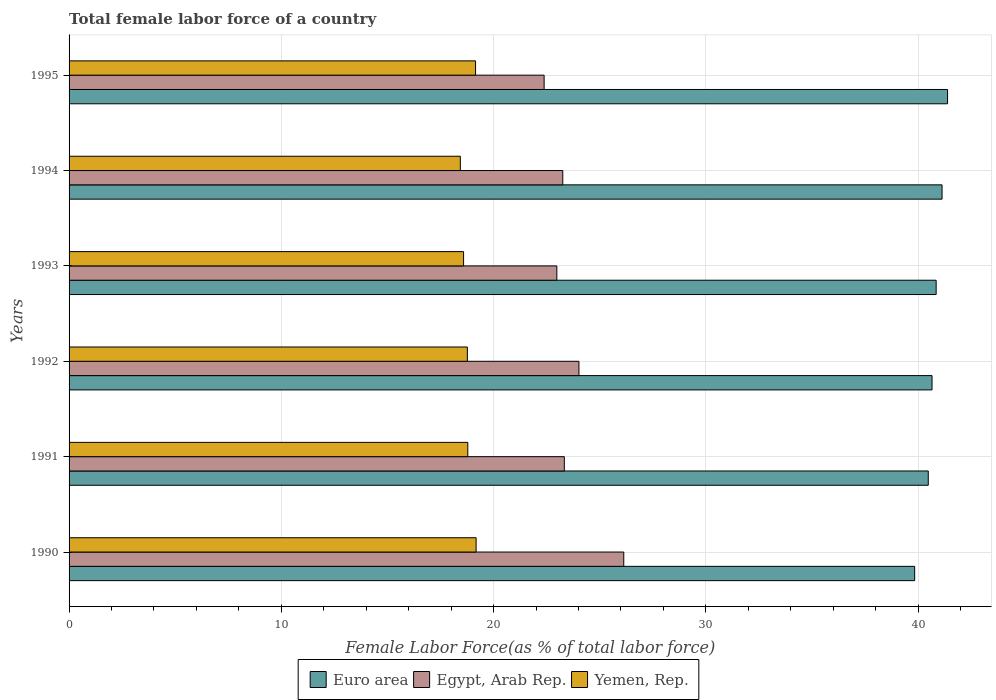How many different coloured bars are there?
Provide a short and direct response. 3. How many groups of bars are there?
Offer a terse response. 6. Are the number of bars per tick equal to the number of legend labels?
Your answer should be compact. Yes. Are the number of bars on each tick of the Y-axis equal?
Give a very brief answer. Yes. How many bars are there on the 5th tick from the top?
Offer a very short reply. 3. What is the label of the 2nd group of bars from the top?
Provide a succinct answer. 1994. In how many cases, is the number of bars for a given year not equal to the number of legend labels?
Make the answer very short. 0. What is the percentage of female labor force in Euro area in 1993?
Provide a succinct answer. 40.85. Across all years, what is the maximum percentage of female labor force in Egypt, Arab Rep.?
Provide a short and direct response. 26.14. Across all years, what is the minimum percentage of female labor force in Egypt, Arab Rep.?
Your answer should be compact. 22.38. In which year was the percentage of female labor force in Egypt, Arab Rep. maximum?
Make the answer very short. 1990. In which year was the percentage of female labor force in Egypt, Arab Rep. minimum?
Ensure brevity in your answer.  1995. What is the total percentage of female labor force in Egypt, Arab Rep. in the graph?
Provide a succinct answer. 142.12. What is the difference between the percentage of female labor force in Egypt, Arab Rep. in 1990 and that in 1991?
Provide a short and direct response. 2.8. What is the difference between the percentage of female labor force in Yemen, Rep. in 1990 and the percentage of female labor force in Euro area in 1994?
Ensure brevity in your answer.  -21.95. What is the average percentage of female labor force in Egypt, Arab Rep. per year?
Make the answer very short. 23.69. In the year 1991, what is the difference between the percentage of female labor force in Yemen, Rep. and percentage of female labor force in Euro area?
Give a very brief answer. -21.7. What is the ratio of the percentage of female labor force in Euro area in 1990 to that in 1992?
Your response must be concise. 0.98. Is the percentage of female labor force in Egypt, Arab Rep. in 1991 less than that in 1993?
Keep it short and to the point. No. What is the difference between the highest and the second highest percentage of female labor force in Yemen, Rep.?
Provide a short and direct response. 0.03. What is the difference between the highest and the lowest percentage of female labor force in Egypt, Arab Rep.?
Give a very brief answer. 3.75. What does the 3rd bar from the bottom in 1995 represents?
Your answer should be compact. Yemen, Rep. Is it the case that in every year, the sum of the percentage of female labor force in Egypt, Arab Rep. and percentage of female labor force in Euro area is greater than the percentage of female labor force in Yemen, Rep.?
Make the answer very short. Yes. Are all the bars in the graph horizontal?
Offer a terse response. Yes. What is the difference between two consecutive major ticks on the X-axis?
Offer a very short reply. 10. Does the graph contain grids?
Provide a succinct answer. Yes. Where does the legend appear in the graph?
Your answer should be very brief. Bottom center. How many legend labels are there?
Give a very brief answer. 3. What is the title of the graph?
Make the answer very short. Total female labor force of a country. What is the label or title of the X-axis?
Keep it short and to the point. Female Labor Force(as % of total labor force). What is the Female Labor Force(as % of total labor force) in Euro area in 1990?
Offer a very short reply. 39.84. What is the Female Labor Force(as % of total labor force) in Egypt, Arab Rep. in 1990?
Your response must be concise. 26.14. What is the Female Labor Force(as % of total labor force) of Yemen, Rep. in 1990?
Provide a succinct answer. 19.18. What is the Female Labor Force(as % of total labor force) of Euro area in 1991?
Your answer should be very brief. 40.48. What is the Female Labor Force(as % of total labor force) in Egypt, Arab Rep. in 1991?
Your answer should be compact. 23.34. What is the Female Labor Force(as % of total labor force) in Yemen, Rep. in 1991?
Make the answer very short. 18.79. What is the Female Labor Force(as % of total labor force) in Euro area in 1992?
Your answer should be very brief. 40.66. What is the Female Labor Force(as % of total labor force) in Egypt, Arab Rep. in 1992?
Provide a succinct answer. 24.02. What is the Female Labor Force(as % of total labor force) of Yemen, Rep. in 1992?
Offer a terse response. 18.77. What is the Female Labor Force(as % of total labor force) of Euro area in 1993?
Your answer should be compact. 40.85. What is the Female Labor Force(as % of total labor force) of Egypt, Arab Rep. in 1993?
Ensure brevity in your answer.  22.98. What is the Female Labor Force(as % of total labor force) of Yemen, Rep. in 1993?
Your response must be concise. 18.59. What is the Female Labor Force(as % of total labor force) in Euro area in 1994?
Give a very brief answer. 41.13. What is the Female Labor Force(as % of total labor force) in Egypt, Arab Rep. in 1994?
Ensure brevity in your answer.  23.26. What is the Female Labor Force(as % of total labor force) of Yemen, Rep. in 1994?
Your answer should be compact. 18.44. What is the Female Labor Force(as % of total labor force) in Euro area in 1995?
Give a very brief answer. 41.39. What is the Female Labor Force(as % of total labor force) of Egypt, Arab Rep. in 1995?
Ensure brevity in your answer.  22.38. What is the Female Labor Force(as % of total labor force) of Yemen, Rep. in 1995?
Your answer should be very brief. 19.15. Across all years, what is the maximum Female Labor Force(as % of total labor force) of Euro area?
Ensure brevity in your answer.  41.39. Across all years, what is the maximum Female Labor Force(as % of total labor force) of Egypt, Arab Rep.?
Your response must be concise. 26.14. Across all years, what is the maximum Female Labor Force(as % of total labor force) in Yemen, Rep.?
Provide a short and direct response. 19.18. Across all years, what is the minimum Female Labor Force(as % of total labor force) in Euro area?
Offer a very short reply. 39.84. Across all years, what is the minimum Female Labor Force(as % of total labor force) of Egypt, Arab Rep.?
Your answer should be very brief. 22.38. Across all years, what is the minimum Female Labor Force(as % of total labor force) in Yemen, Rep.?
Keep it short and to the point. 18.44. What is the total Female Labor Force(as % of total labor force) of Euro area in the graph?
Offer a very short reply. 244.36. What is the total Female Labor Force(as % of total labor force) of Egypt, Arab Rep. in the graph?
Provide a succinct answer. 142.12. What is the total Female Labor Force(as % of total labor force) of Yemen, Rep. in the graph?
Ensure brevity in your answer.  112.91. What is the difference between the Female Labor Force(as % of total labor force) in Euro area in 1990 and that in 1991?
Give a very brief answer. -0.64. What is the difference between the Female Labor Force(as % of total labor force) in Yemen, Rep. in 1990 and that in 1991?
Ensure brevity in your answer.  0.39. What is the difference between the Female Labor Force(as % of total labor force) in Euro area in 1990 and that in 1992?
Your answer should be very brief. -0.82. What is the difference between the Female Labor Force(as % of total labor force) of Egypt, Arab Rep. in 1990 and that in 1992?
Offer a terse response. 2.11. What is the difference between the Female Labor Force(as % of total labor force) of Yemen, Rep. in 1990 and that in 1992?
Your response must be concise. 0.41. What is the difference between the Female Labor Force(as % of total labor force) in Euro area in 1990 and that in 1993?
Keep it short and to the point. -1.01. What is the difference between the Female Labor Force(as % of total labor force) in Egypt, Arab Rep. in 1990 and that in 1993?
Offer a very short reply. 3.15. What is the difference between the Female Labor Force(as % of total labor force) of Yemen, Rep. in 1990 and that in 1993?
Ensure brevity in your answer.  0.59. What is the difference between the Female Labor Force(as % of total labor force) of Euro area in 1990 and that in 1994?
Give a very brief answer. -1.29. What is the difference between the Female Labor Force(as % of total labor force) in Egypt, Arab Rep. in 1990 and that in 1994?
Provide a short and direct response. 2.87. What is the difference between the Female Labor Force(as % of total labor force) in Yemen, Rep. in 1990 and that in 1994?
Offer a very short reply. 0.74. What is the difference between the Female Labor Force(as % of total labor force) in Euro area in 1990 and that in 1995?
Your response must be concise. -1.55. What is the difference between the Female Labor Force(as % of total labor force) in Egypt, Arab Rep. in 1990 and that in 1995?
Offer a terse response. 3.75. What is the difference between the Female Labor Force(as % of total labor force) of Yemen, Rep. in 1990 and that in 1995?
Give a very brief answer. 0.03. What is the difference between the Female Labor Force(as % of total labor force) of Euro area in 1991 and that in 1992?
Provide a short and direct response. -0.18. What is the difference between the Female Labor Force(as % of total labor force) in Egypt, Arab Rep. in 1991 and that in 1992?
Your answer should be very brief. -0.69. What is the difference between the Female Labor Force(as % of total labor force) in Yemen, Rep. in 1991 and that in 1992?
Provide a succinct answer. 0.02. What is the difference between the Female Labor Force(as % of total labor force) in Euro area in 1991 and that in 1993?
Provide a succinct answer. -0.37. What is the difference between the Female Labor Force(as % of total labor force) of Egypt, Arab Rep. in 1991 and that in 1993?
Provide a short and direct response. 0.35. What is the difference between the Female Labor Force(as % of total labor force) in Yemen, Rep. in 1991 and that in 1993?
Your answer should be compact. 0.2. What is the difference between the Female Labor Force(as % of total labor force) of Euro area in 1991 and that in 1994?
Offer a terse response. -0.65. What is the difference between the Female Labor Force(as % of total labor force) of Egypt, Arab Rep. in 1991 and that in 1994?
Your answer should be very brief. 0.07. What is the difference between the Female Labor Force(as % of total labor force) in Yemen, Rep. in 1991 and that in 1994?
Make the answer very short. 0.35. What is the difference between the Female Labor Force(as % of total labor force) in Euro area in 1991 and that in 1995?
Provide a succinct answer. -0.91. What is the difference between the Female Labor Force(as % of total labor force) of Egypt, Arab Rep. in 1991 and that in 1995?
Your response must be concise. 0.95. What is the difference between the Female Labor Force(as % of total labor force) in Yemen, Rep. in 1991 and that in 1995?
Offer a terse response. -0.37. What is the difference between the Female Labor Force(as % of total labor force) in Euro area in 1992 and that in 1993?
Keep it short and to the point. -0.19. What is the difference between the Female Labor Force(as % of total labor force) of Egypt, Arab Rep. in 1992 and that in 1993?
Your response must be concise. 1.04. What is the difference between the Female Labor Force(as % of total labor force) of Yemen, Rep. in 1992 and that in 1993?
Offer a terse response. 0.18. What is the difference between the Female Labor Force(as % of total labor force) of Euro area in 1992 and that in 1994?
Your response must be concise. -0.47. What is the difference between the Female Labor Force(as % of total labor force) in Egypt, Arab Rep. in 1992 and that in 1994?
Your response must be concise. 0.76. What is the difference between the Female Labor Force(as % of total labor force) of Yemen, Rep. in 1992 and that in 1994?
Ensure brevity in your answer.  0.33. What is the difference between the Female Labor Force(as % of total labor force) of Euro area in 1992 and that in 1995?
Your response must be concise. -0.73. What is the difference between the Female Labor Force(as % of total labor force) of Egypt, Arab Rep. in 1992 and that in 1995?
Your response must be concise. 1.64. What is the difference between the Female Labor Force(as % of total labor force) of Yemen, Rep. in 1992 and that in 1995?
Ensure brevity in your answer.  -0.39. What is the difference between the Female Labor Force(as % of total labor force) in Euro area in 1993 and that in 1994?
Give a very brief answer. -0.28. What is the difference between the Female Labor Force(as % of total labor force) in Egypt, Arab Rep. in 1993 and that in 1994?
Provide a succinct answer. -0.28. What is the difference between the Female Labor Force(as % of total labor force) in Yemen, Rep. in 1993 and that in 1994?
Offer a terse response. 0.15. What is the difference between the Female Labor Force(as % of total labor force) in Euro area in 1993 and that in 1995?
Make the answer very short. -0.54. What is the difference between the Female Labor Force(as % of total labor force) of Egypt, Arab Rep. in 1993 and that in 1995?
Keep it short and to the point. 0.6. What is the difference between the Female Labor Force(as % of total labor force) of Yemen, Rep. in 1993 and that in 1995?
Keep it short and to the point. -0.56. What is the difference between the Female Labor Force(as % of total labor force) in Euro area in 1994 and that in 1995?
Your response must be concise. -0.26. What is the difference between the Female Labor Force(as % of total labor force) of Egypt, Arab Rep. in 1994 and that in 1995?
Offer a terse response. 0.88. What is the difference between the Female Labor Force(as % of total labor force) in Yemen, Rep. in 1994 and that in 1995?
Your answer should be very brief. -0.72. What is the difference between the Female Labor Force(as % of total labor force) in Euro area in 1990 and the Female Labor Force(as % of total labor force) in Egypt, Arab Rep. in 1991?
Make the answer very short. 16.51. What is the difference between the Female Labor Force(as % of total labor force) in Euro area in 1990 and the Female Labor Force(as % of total labor force) in Yemen, Rep. in 1991?
Make the answer very short. 21.06. What is the difference between the Female Labor Force(as % of total labor force) of Egypt, Arab Rep. in 1990 and the Female Labor Force(as % of total labor force) of Yemen, Rep. in 1991?
Your answer should be compact. 7.35. What is the difference between the Female Labor Force(as % of total labor force) of Euro area in 1990 and the Female Labor Force(as % of total labor force) of Egypt, Arab Rep. in 1992?
Provide a succinct answer. 15.82. What is the difference between the Female Labor Force(as % of total labor force) in Euro area in 1990 and the Female Labor Force(as % of total labor force) in Yemen, Rep. in 1992?
Make the answer very short. 21.08. What is the difference between the Female Labor Force(as % of total labor force) in Egypt, Arab Rep. in 1990 and the Female Labor Force(as % of total labor force) in Yemen, Rep. in 1992?
Your answer should be very brief. 7.37. What is the difference between the Female Labor Force(as % of total labor force) of Euro area in 1990 and the Female Labor Force(as % of total labor force) of Egypt, Arab Rep. in 1993?
Provide a succinct answer. 16.86. What is the difference between the Female Labor Force(as % of total labor force) of Euro area in 1990 and the Female Labor Force(as % of total labor force) of Yemen, Rep. in 1993?
Offer a very short reply. 21.25. What is the difference between the Female Labor Force(as % of total labor force) of Egypt, Arab Rep. in 1990 and the Female Labor Force(as % of total labor force) of Yemen, Rep. in 1993?
Provide a succinct answer. 7.55. What is the difference between the Female Labor Force(as % of total labor force) in Euro area in 1990 and the Female Labor Force(as % of total labor force) in Egypt, Arab Rep. in 1994?
Provide a succinct answer. 16.58. What is the difference between the Female Labor Force(as % of total labor force) of Euro area in 1990 and the Female Labor Force(as % of total labor force) of Yemen, Rep. in 1994?
Offer a very short reply. 21.41. What is the difference between the Female Labor Force(as % of total labor force) in Euro area in 1990 and the Female Labor Force(as % of total labor force) in Egypt, Arab Rep. in 1995?
Offer a terse response. 17.46. What is the difference between the Female Labor Force(as % of total labor force) in Euro area in 1990 and the Female Labor Force(as % of total labor force) in Yemen, Rep. in 1995?
Provide a succinct answer. 20.69. What is the difference between the Female Labor Force(as % of total labor force) in Egypt, Arab Rep. in 1990 and the Female Labor Force(as % of total labor force) in Yemen, Rep. in 1995?
Your answer should be compact. 6.98. What is the difference between the Female Labor Force(as % of total labor force) of Euro area in 1991 and the Female Labor Force(as % of total labor force) of Egypt, Arab Rep. in 1992?
Provide a short and direct response. 16.46. What is the difference between the Female Labor Force(as % of total labor force) in Euro area in 1991 and the Female Labor Force(as % of total labor force) in Yemen, Rep. in 1992?
Give a very brief answer. 21.72. What is the difference between the Female Labor Force(as % of total labor force) in Egypt, Arab Rep. in 1991 and the Female Labor Force(as % of total labor force) in Yemen, Rep. in 1992?
Offer a very short reply. 4.57. What is the difference between the Female Labor Force(as % of total labor force) in Euro area in 1991 and the Female Labor Force(as % of total labor force) in Egypt, Arab Rep. in 1993?
Make the answer very short. 17.5. What is the difference between the Female Labor Force(as % of total labor force) in Euro area in 1991 and the Female Labor Force(as % of total labor force) in Yemen, Rep. in 1993?
Your answer should be very brief. 21.89. What is the difference between the Female Labor Force(as % of total labor force) in Egypt, Arab Rep. in 1991 and the Female Labor Force(as % of total labor force) in Yemen, Rep. in 1993?
Your answer should be compact. 4.75. What is the difference between the Female Labor Force(as % of total labor force) of Euro area in 1991 and the Female Labor Force(as % of total labor force) of Egypt, Arab Rep. in 1994?
Keep it short and to the point. 17.22. What is the difference between the Female Labor Force(as % of total labor force) of Euro area in 1991 and the Female Labor Force(as % of total labor force) of Yemen, Rep. in 1994?
Give a very brief answer. 22.05. What is the difference between the Female Labor Force(as % of total labor force) in Egypt, Arab Rep. in 1991 and the Female Labor Force(as % of total labor force) in Yemen, Rep. in 1994?
Offer a terse response. 4.9. What is the difference between the Female Labor Force(as % of total labor force) of Euro area in 1991 and the Female Labor Force(as % of total labor force) of Egypt, Arab Rep. in 1995?
Your response must be concise. 18.1. What is the difference between the Female Labor Force(as % of total labor force) in Euro area in 1991 and the Female Labor Force(as % of total labor force) in Yemen, Rep. in 1995?
Keep it short and to the point. 21.33. What is the difference between the Female Labor Force(as % of total labor force) in Egypt, Arab Rep. in 1991 and the Female Labor Force(as % of total labor force) in Yemen, Rep. in 1995?
Ensure brevity in your answer.  4.18. What is the difference between the Female Labor Force(as % of total labor force) of Euro area in 1992 and the Female Labor Force(as % of total labor force) of Egypt, Arab Rep. in 1993?
Ensure brevity in your answer.  17.68. What is the difference between the Female Labor Force(as % of total labor force) in Euro area in 1992 and the Female Labor Force(as % of total labor force) in Yemen, Rep. in 1993?
Your response must be concise. 22.07. What is the difference between the Female Labor Force(as % of total labor force) of Egypt, Arab Rep. in 1992 and the Female Labor Force(as % of total labor force) of Yemen, Rep. in 1993?
Offer a terse response. 5.44. What is the difference between the Female Labor Force(as % of total labor force) of Euro area in 1992 and the Female Labor Force(as % of total labor force) of Egypt, Arab Rep. in 1994?
Your answer should be compact. 17.4. What is the difference between the Female Labor Force(as % of total labor force) in Euro area in 1992 and the Female Labor Force(as % of total labor force) in Yemen, Rep. in 1994?
Your answer should be very brief. 22.22. What is the difference between the Female Labor Force(as % of total labor force) of Egypt, Arab Rep. in 1992 and the Female Labor Force(as % of total labor force) of Yemen, Rep. in 1994?
Ensure brevity in your answer.  5.59. What is the difference between the Female Labor Force(as % of total labor force) in Euro area in 1992 and the Female Labor Force(as % of total labor force) in Egypt, Arab Rep. in 1995?
Keep it short and to the point. 18.28. What is the difference between the Female Labor Force(as % of total labor force) in Euro area in 1992 and the Female Labor Force(as % of total labor force) in Yemen, Rep. in 1995?
Ensure brevity in your answer.  21.51. What is the difference between the Female Labor Force(as % of total labor force) of Egypt, Arab Rep. in 1992 and the Female Labor Force(as % of total labor force) of Yemen, Rep. in 1995?
Keep it short and to the point. 4.87. What is the difference between the Female Labor Force(as % of total labor force) in Euro area in 1993 and the Female Labor Force(as % of total labor force) in Egypt, Arab Rep. in 1994?
Provide a short and direct response. 17.59. What is the difference between the Female Labor Force(as % of total labor force) of Euro area in 1993 and the Female Labor Force(as % of total labor force) of Yemen, Rep. in 1994?
Provide a short and direct response. 22.42. What is the difference between the Female Labor Force(as % of total labor force) of Egypt, Arab Rep. in 1993 and the Female Labor Force(as % of total labor force) of Yemen, Rep. in 1994?
Give a very brief answer. 4.55. What is the difference between the Female Labor Force(as % of total labor force) of Euro area in 1993 and the Female Labor Force(as % of total labor force) of Egypt, Arab Rep. in 1995?
Provide a short and direct response. 18.47. What is the difference between the Female Labor Force(as % of total labor force) of Euro area in 1993 and the Female Labor Force(as % of total labor force) of Yemen, Rep. in 1995?
Ensure brevity in your answer.  21.7. What is the difference between the Female Labor Force(as % of total labor force) in Egypt, Arab Rep. in 1993 and the Female Labor Force(as % of total labor force) in Yemen, Rep. in 1995?
Give a very brief answer. 3.83. What is the difference between the Female Labor Force(as % of total labor force) of Euro area in 1994 and the Female Labor Force(as % of total labor force) of Egypt, Arab Rep. in 1995?
Your answer should be very brief. 18.75. What is the difference between the Female Labor Force(as % of total labor force) of Euro area in 1994 and the Female Labor Force(as % of total labor force) of Yemen, Rep. in 1995?
Provide a succinct answer. 21.98. What is the difference between the Female Labor Force(as % of total labor force) of Egypt, Arab Rep. in 1994 and the Female Labor Force(as % of total labor force) of Yemen, Rep. in 1995?
Keep it short and to the point. 4.11. What is the average Female Labor Force(as % of total labor force) in Euro area per year?
Your answer should be compact. 40.73. What is the average Female Labor Force(as % of total labor force) in Egypt, Arab Rep. per year?
Keep it short and to the point. 23.69. What is the average Female Labor Force(as % of total labor force) in Yemen, Rep. per year?
Make the answer very short. 18.82. In the year 1990, what is the difference between the Female Labor Force(as % of total labor force) of Euro area and Female Labor Force(as % of total labor force) of Egypt, Arab Rep.?
Make the answer very short. 13.71. In the year 1990, what is the difference between the Female Labor Force(as % of total labor force) in Euro area and Female Labor Force(as % of total labor force) in Yemen, Rep.?
Your answer should be compact. 20.66. In the year 1990, what is the difference between the Female Labor Force(as % of total labor force) in Egypt, Arab Rep. and Female Labor Force(as % of total labor force) in Yemen, Rep.?
Offer a terse response. 6.96. In the year 1991, what is the difference between the Female Labor Force(as % of total labor force) of Euro area and Female Labor Force(as % of total labor force) of Egypt, Arab Rep.?
Provide a short and direct response. 17.15. In the year 1991, what is the difference between the Female Labor Force(as % of total labor force) of Euro area and Female Labor Force(as % of total labor force) of Yemen, Rep.?
Provide a succinct answer. 21.7. In the year 1991, what is the difference between the Female Labor Force(as % of total labor force) in Egypt, Arab Rep. and Female Labor Force(as % of total labor force) in Yemen, Rep.?
Provide a short and direct response. 4.55. In the year 1992, what is the difference between the Female Labor Force(as % of total labor force) of Euro area and Female Labor Force(as % of total labor force) of Egypt, Arab Rep.?
Offer a terse response. 16.64. In the year 1992, what is the difference between the Female Labor Force(as % of total labor force) of Euro area and Female Labor Force(as % of total labor force) of Yemen, Rep.?
Offer a very short reply. 21.89. In the year 1992, what is the difference between the Female Labor Force(as % of total labor force) of Egypt, Arab Rep. and Female Labor Force(as % of total labor force) of Yemen, Rep.?
Offer a very short reply. 5.26. In the year 1993, what is the difference between the Female Labor Force(as % of total labor force) of Euro area and Female Labor Force(as % of total labor force) of Egypt, Arab Rep.?
Make the answer very short. 17.87. In the year 1993, what is the difference between the Female Labor Force(as % of total labor force) in Euro area and Female Labor Force(as % of total labor force) in Yemen, Rep.?
Offer a very short reply. 22.27. In the year 1993, what is the difference between the Female Labor Force(as % of total labor force) of Egypt, Arab Rep. and Female Labor Force(as % of total labor force) of Yemen, Rep.?
Your answer should be very brief. 4.39. In the year 1994, what is the difference between the Female Labor Force(as % of total labor force) in Euro area and Female Labor Force(as % of total labor force) in Egypt, Arab Rep.?
Offer a terse response. 17.87. In the year 1994, what is the difference between the Female Labor Force(as % of total labor force) in Euro area and Female Labor Force(as % of total labor force) in Yemen, Rep.?
Offer a terse response. 22.7. In the year 1994, what is the difference between the Female Labor Force(as % of total labor force) of Egypt, Arab Rep. and Female Labor Force(as % of total labor force) of Yemen, Rep.?
Your answer should be very brief. 4.83. In the year 1995, what is the difference between the Female Labor Force(as % of total labor force) in Euro area and Female Labor Force(as % of total labor force) in Egypt, Arab Rep.?
Give a very brief answer. 19.01. In the year 1995, what is the difference between the Female Labor Force(as % of total labor force) in Euro area and Female Labor Force(as % of total labor force) in Yemen, Rep.?
Provide a succinct answer. 22.24. In the year 1995, what is the difference between the Female Labor Force(as % of total labor force) of Egypt, Arab Rep. and Female Labor Force(as % of total labor force) of Yemen, Rep.?
Provide a succinct answer. 3.23. What is the ratio of the Female Labor Force(as % of total labor force) of Euro area in 1990 to that in 1991?
Your response must be concise. 0.98. What is the ratio of the Female Labor Force(as % of total labor force) of Egypt, Arab Rep. in 1990 to that in 1991?
Provide a succinct answer. 1.12. What is the ratio of the Female Labor Force(as % of total labor force) in Yemen, Rep. in 1990 to that in 1991?
Your answer should be very brief. 1.02. What is the ratio of the Female Labor Force(as % of total labor force) in Euro area in 1990 to that in 1992?
Offer a terse response. 0.98. What is the ratio of the Female Labor Force(as % of total labor force) in Egypt, Arab Rep. in 1990 to that in 1992?
Your response must be concise. 1.09. What is the ratio of the Female Labor Force(as % of total labor force) in Yemen, Rep. in 1990 to that in 1992?
Your response must be concise. 1.02. What is the ratio of the Female Labor Force(as % of total labor force) of Euro area in 1990 to that in 1993?
Ensure brevity in your answer.  0.98. What is the ratio of the Female Labor Force(as % of total labor force) of Egypt, Arab Rep. in 1990 to that in 1993?
Your answer should be very brief. 1.14. What is the ratio of the Female Labor Force(as % of total labor force) in Yemen, Rep. in 1990 to that in 1993?
Ensure brevity in your answer.  1.03. What is the ratio of the Female Labor Force(as % of total labor force) of Euro area in 1990 to that in 1994?
Make the answer very short. 0.97. What is the ratio of the Female Labor Force(as % of total labor force) in Egypt, Arab Rep. in 1990 to that in 1994?
Keep it short and to the point. 1.12. What is the ratio of the Female Labor Force(as % of total labor force) in Yemen, Rep. in 1990 to that in 1994?
Your answer should be very brief. 1.04. What is the ratio of the Female Labor Force(as % of total labor force) of Euro area in 1990 to that in 1995?
Your answer should be compact. 0.96. What is the ratio of the Female Labor Force(as % of total labor force) of Egypt, Arab Rep. in 1990 to that in 1995?
Offer a very short reply. 1.17. What is the ratio of the Female Labor Force(as % of total labor force) in Yemen, Rep. in 1990 to that in 1995?
Give a very brief answer. 1. What is the ratio of the Female Labor Force(as % of total labor force) in Egypt, Arab Rep. in 1991 to that in 1992?
Provide a short and direct response. 0.97. What is the ratio of the Female Labor Force(as % of total labor force) in Euro area in 1991 to that in 1993?
Make the answer very short. 0.99. What is the ratio of the Female Labor Force(as % of total labor force) in Egypt, Arab Rep. in 1991 to that in 1993?
Ensure brevity in your answer.  1.02. What is the ratio of the Female Labor Force(as % of total labor force) in Yemen, Rep. in 1991 to that in 1993?
Your response must be concise. 1.01. What is the ratio of the Female Labor Force(as % of total labor force) in Euro area in 1991 to that in 1994?
Ensure brevity in your answer.  0.98. What is the ratio of the Female Labor Force(as % of total labor force) of Yemen, Rep. in 1991 to that in 1994?
Offer a terse response. 1.02. What is the ratio of the Female Labor Force(as % of total labor force) in Euro area in 1991 to that in 1995?
Keep it short and to the point. 0.98. What is the ratio of the Female Labor Force(as % of total labor force) in Egypt, Arab Rep. in 1991 to that in 1995?
Ensure brevity in your answer.  1.04. What is the ratio of the Female Labor Force(as % of total labor force) in Yemen, Rep. in 1991 to that in 1995?
Offer a terse response. 0.98. What is the ratio of the Female Labor Force(as % of total labor force) in Egypt, Arab Rep. in 1992 to that in 1993?
Your response must be concise. 1.05. What is the ratio of the Female Labor Force(as % of total labor force) in Yemen, Rep. in 1992 to that in 1993?
Your response must be concise. 1.01. What is the ratio of the Female Labor Force(as % of total labor force) of Euro area in 1992 to that in 1994?
Make the answer very short. 0.99. What is the ratio of the Female Labor Force(as % of total labor force) in Egypt, Arab Rep. in 1992 to that in 1994?
Give a very brief answer. 1.03. What is the ratio of the Female Labor Force(as % of total labor force) of Yemen, Rep. in 1992 to that in 1994?
Provide a succinct answer. 1.02. What is the ratio of the Female Labor Force(as % of total labor force) in Euro area in 1992 to that in 1995?
Give a very brief answer. 0.98. What is the ratio of the Female Labor Force(as % of total labor force) in Egypt, Arab Rep. in 1992 to that in 1995?
Ensure brevity in your answer.  1.07. What is the ratio of the Female Labor Force(as % of total labor force) of Yemen, Rep. in 1992 to that in 1995?
Your answer should be compact. 0.98. What is the ratio of the Female Labor Force(as % of total labor force) of Yemen, Rep. in 1993 to that in 1994?
Make the answer very short. 1.01. What is the ratio of the Female Labor Force(as % of total labor force) in Euro area in 1993 to that in 1995?
Your answer should be very brief. 0.99. What is the ratio of the Female Labor Force(as % of total labor force) of Egypt, Arab Rep. in 1993 to that in 1995?
Make the answer very short. 1.03. What is the ratio of the Female Labor Force(as % of total labor force) in Yemen, Rep. in 1993 to that in 1995?
Your response must be concise. 0.97. What is the ratio of the Female Labor Force(as % of total labor force) of Euro area in 1994 to that in 1995?
Ensure brevity in your answer.  0.99. What is the ratio of the Female Labor Force(as % of total labor force) of Egypt, Arab Rep. in 1994 to that in 1995?
Keep it short and to the point. 1.04. What is the ratio of the Female Labor Force(as % of total labor force) in Yemen, Rep. in 1994 to that in 1995?
Your response must be concise. 0.96. What is the difference between the highest and the second highest Female Labor Force(as % of total labor force) in Euro area?
Make the answer very short. 0.26. What is the difference between the highest and the second highest Female Labor Force(as % of total labor force) in Egypt, Arab Rep.?
Provide a short and direct response. 2.11. What is the difference between the highest and the second highest Female Labor Force(as % of total labor force) in Yemen, Rep.?
Ensure brevity in your answer.  0.03. What is the difference between the highest and the lowest Female Labor Force(as % of total labor force) of Euro area?
Give a very brief answer. 1.55. What is the difference between the highest and the lowest Female Labor Force(as % of total labor force) in Egypt, Arab Rep.?
Your answer should be very brief. 3.75. What is the difference between the highest and the lowest Female Labor Force(as % of total labor force) of Yemen, Rep.?
Provide a succinct answer. 0.74. 